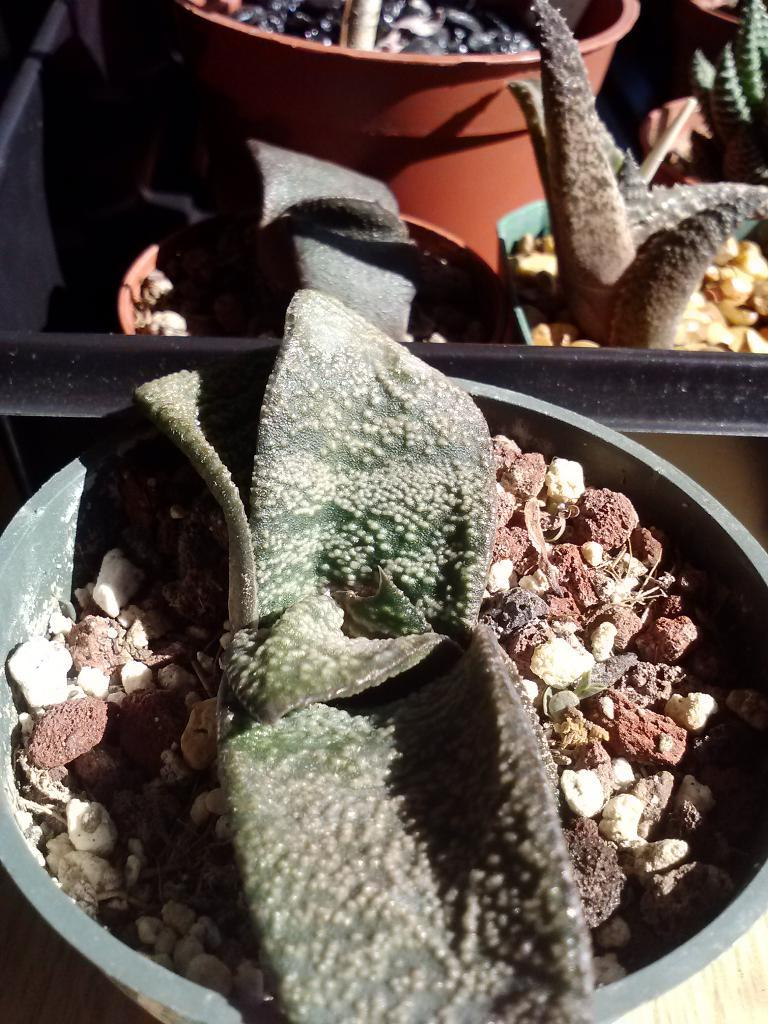What can be seen in the spots in the image? The spots in the image are filled with plants and stones. Can you describe the appearance of the spots? The spots are filled with both plants and stones. What achievements has the mother in the image accomplished? There is no mother present in the image, so it is not possible to discuss her achievements. 